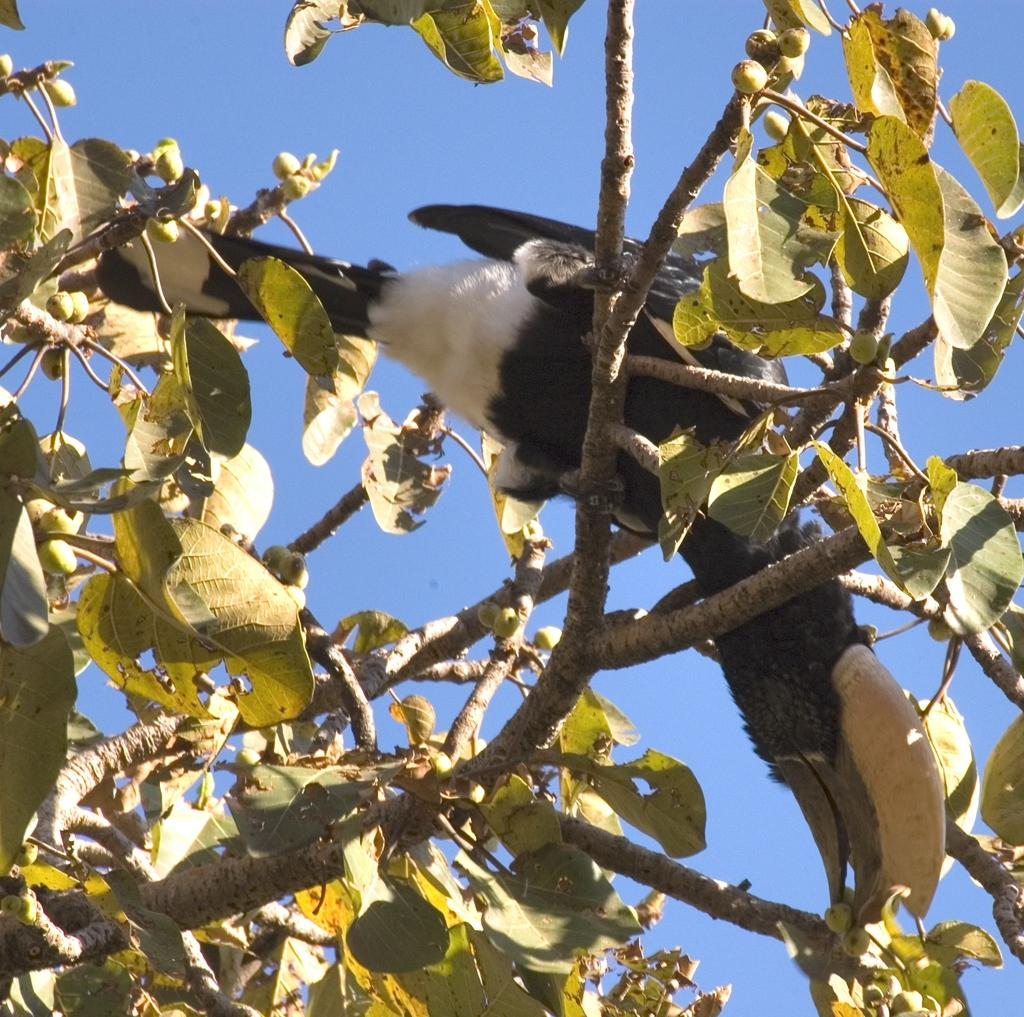What type of animal can be seen in the image? There is a bird in the image. What is the bird perched on in the image? The bird is perched on a tree in the image. What can be seen in the background of the image? The sky is visible in the background of the image. What committee is responsible for the bird's presence in the image? There is no committee responsible for the bird's presence in the image; it is a natural occurrence. 